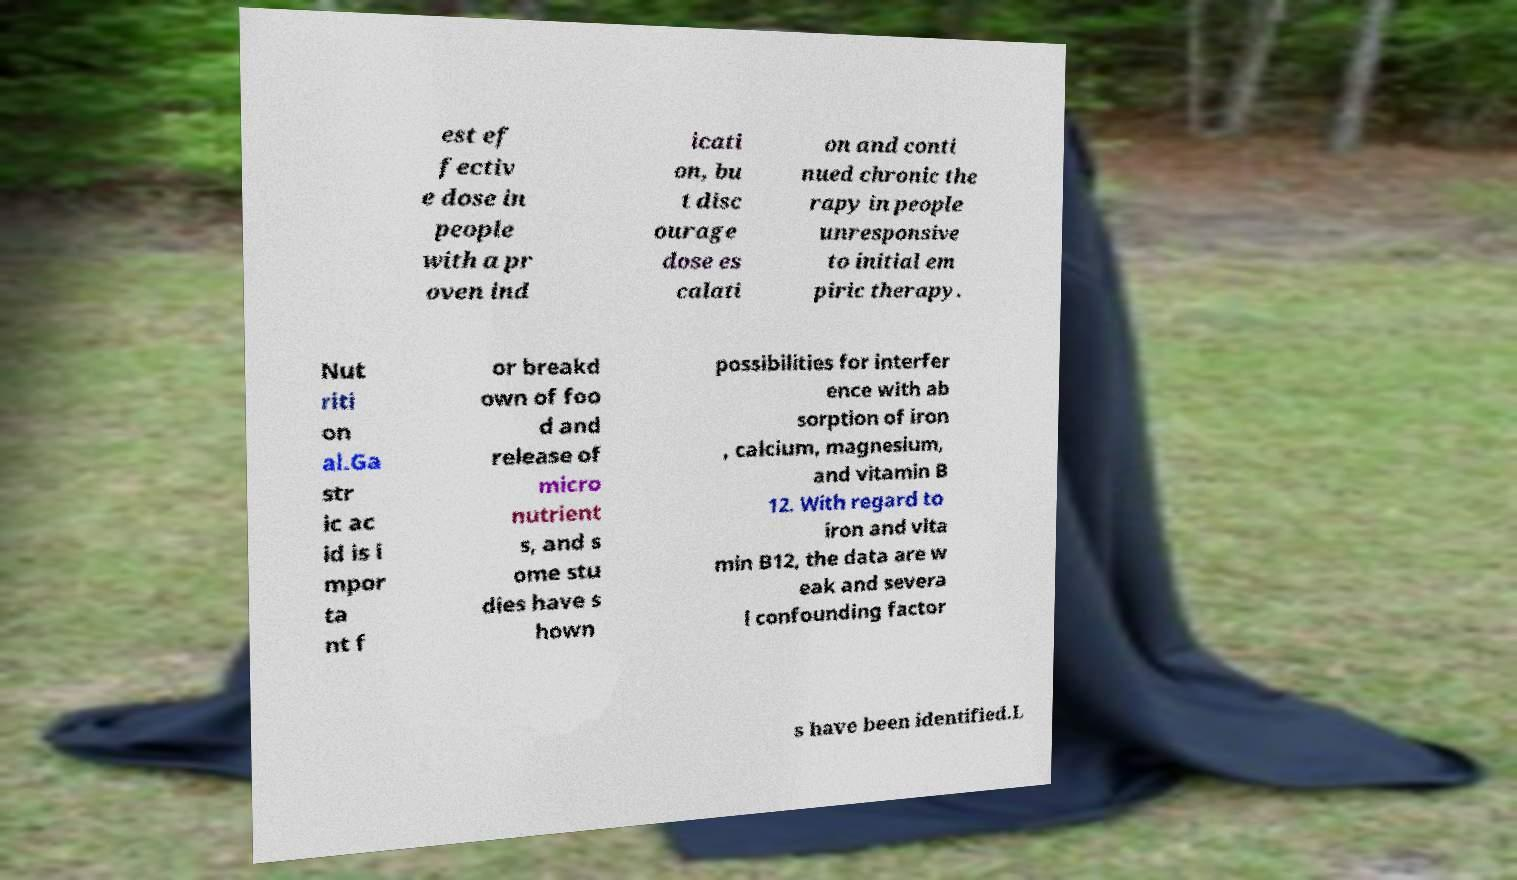Please read and relay the text visible in this image. What does it say? est ef fectiv e dose in people with a pr oven ind icati on, bu t disc ourage dose es calati on and conti nued chronic the rapy in people unresponsive to initial em piric therapy. Nut riti on al.Ga str ic ac id is i mpor ta nt f or breakd own of foo d and release of micro nutrient s, and s ome stu dies have s hown possibilities for interfer ence with ab sorption of iron , calcium, magnesium, and vitamin B 12. With regard to iron and vita min B12, the data are w eak and severa l confounding factor s have been identified.L 